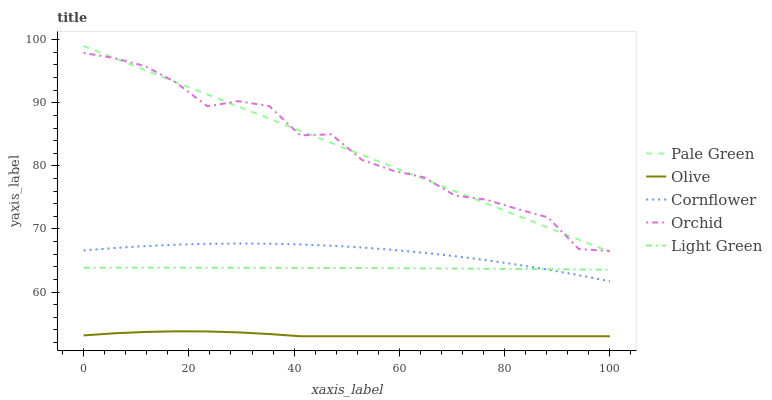Does Olive have the minimum area under the curve?
Answer yes or no. Yes. Does Orchid have the maximum area under the curve?
Answer yes or no. Yes. Does Cornflower have the minimum area under the curve?
Answer yes or no. No. Does Cornflower have the maximum area under the curve?
Answer yes or no. No. Is Pale Green the smoothest?
Answer yes or no. Yes. Is Orchid the roughest?
Answer yes or no. Yes. Is Cornflower the smoothest?
Answer yes or no. No. Is Cornflower the roughest?
Answer yes or no. No. Does Cornflower have the lowest value?
Answer yes or no. No. Does Pale Green have the highest value?
Answer yes or no. Yes. Does Cornflower have the highest value?
Answer yes or no. No. Is Cornflower less than Orchid?
Answer yes or no. Yes. Is Orchid greater than Cornflower?
Answer yes or no. Yes. Does Cornflower intersect Light Green?
Answer yes or no. Yes. Is Cornflower less than Light Green?
Answer yes or no. No. Is Cornflower greater than Light Green?
Answer yes or no. No. Does Cornflower intersect Orchid?
Answer yes or no. No. 